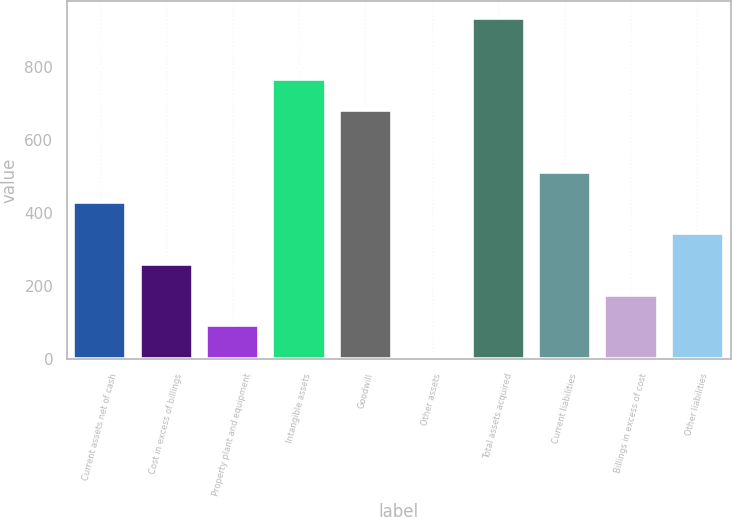<chart> <loc_0><loc_0><loc_500><loc_500><bar_chart><fcel>Current assets net of cash<fcel>Cost in excess of billings<fcel>Property plant and equipment<fcel>Intangible assets<fcel>Goodwill<fcel>Other assets<fcel>Total assets acquired<fcel>Current liabilities<fcel>Billings in excess of cost<fcel>Other liabilities<nl><fcel>429<fcel>260.6<fcel>92.2<fcel>765.8<fcel>681.6<fcel>8<fcel>934.2<fcel>513.2<fcel>176.4<fcel>344.8<nl></chart> 